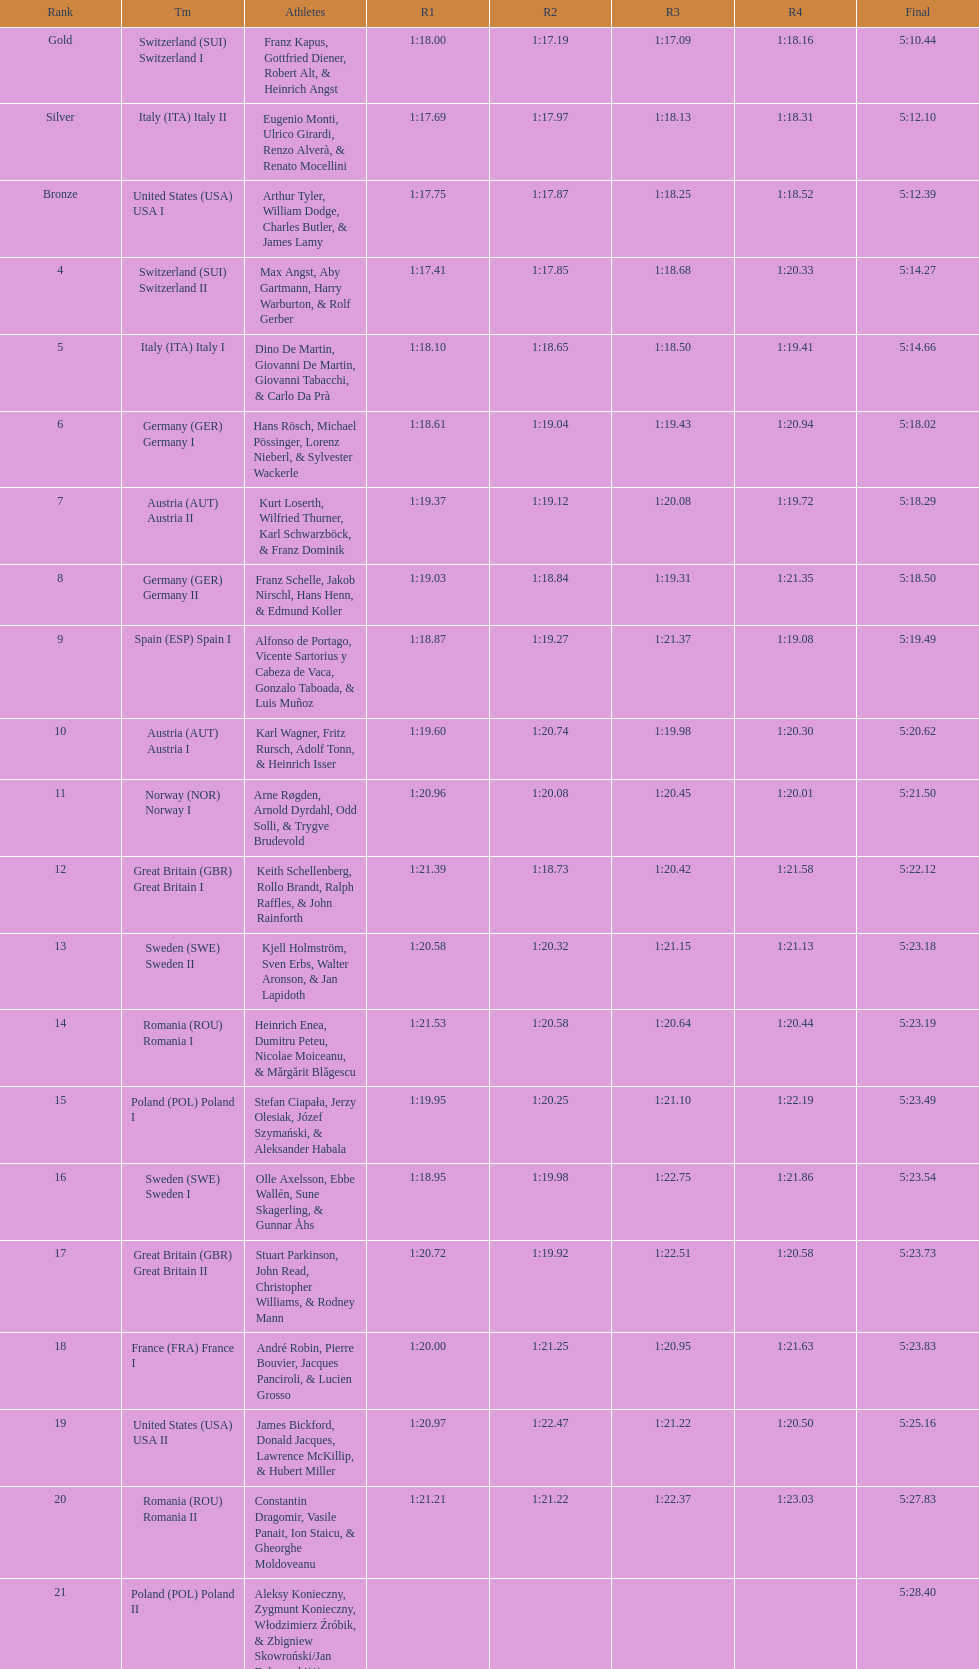Which group ranked just above last place? Romania. 